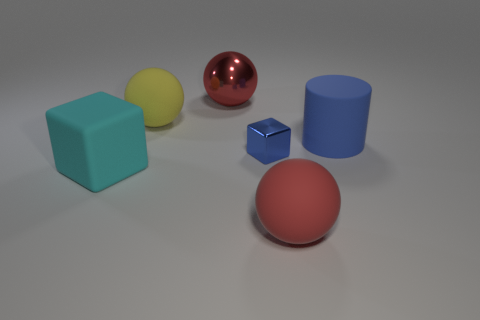What number of other things are there of the same material as the big yellow sphere
Your answer should be very brief. 3. How many large yellow balls are to the right of the large red thing behind the red sphere right of the small blue metallic thing?
Your response must be concise. 0. Are there any other things that are the same size as the blue shiny thing?
Give a very brief answer. No. Is the size of the metallic sphere the same as the rubber ball that is in front of the large blue cylinder?
Give a very brief answer. Yes. What number of tiny red matte cylinders are there?
Give a very brief answer. 0. There is a rubber sphere to the right of the blue shiny cube; is its size the same as the red object left of the red matte object?
Ensure brevity in your answer.  Yes. There is a rubber thing that is the same shape as the tiny blue metallic object; what is its color?
Provide a short and direct response. Cyan. Does the cyan rubber object have the same shape as the small object?
Your answer should be very brief. Yes. What size is the other object that is the same shape as the cyan rubber thing?
Your answer should be very brief. Small. How many tiny blue blocks are the same material as the small object?
Your answer should be compact. 0. 